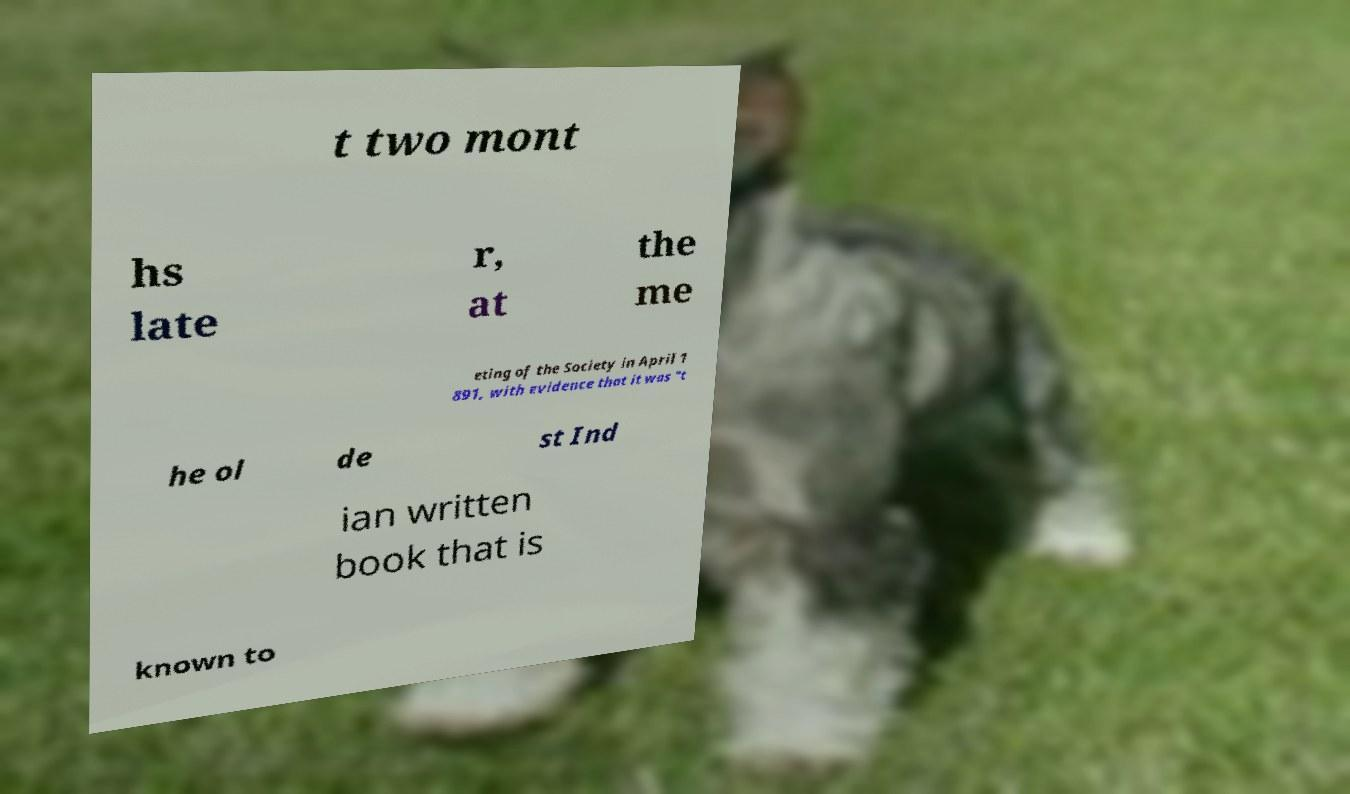Please identify and transcribe the text found in this image. t two mont hs late r, at the me eting of the Society in April 1 891, with evidence that it was "t he ol de st Ind ian written book that is known to 